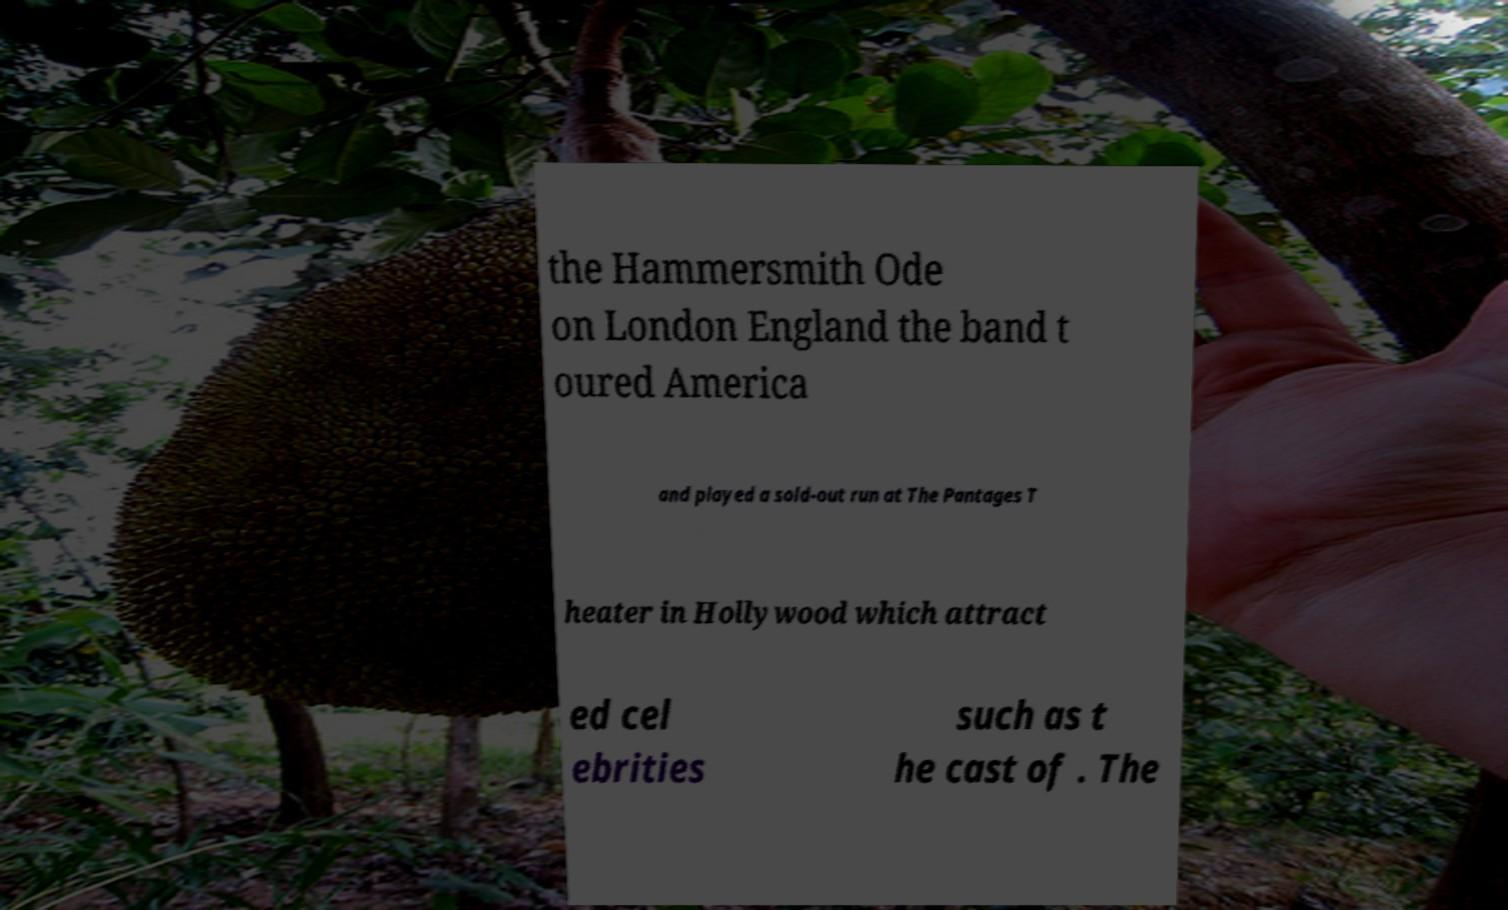I need the written content from this picture converted into text. Can you do that? the Hammersmith Ode on London England the band t oured America and played a sold-out run at The Pantages T heater in Hollywood which attract ed cel ebrities such as t he cast of . The 